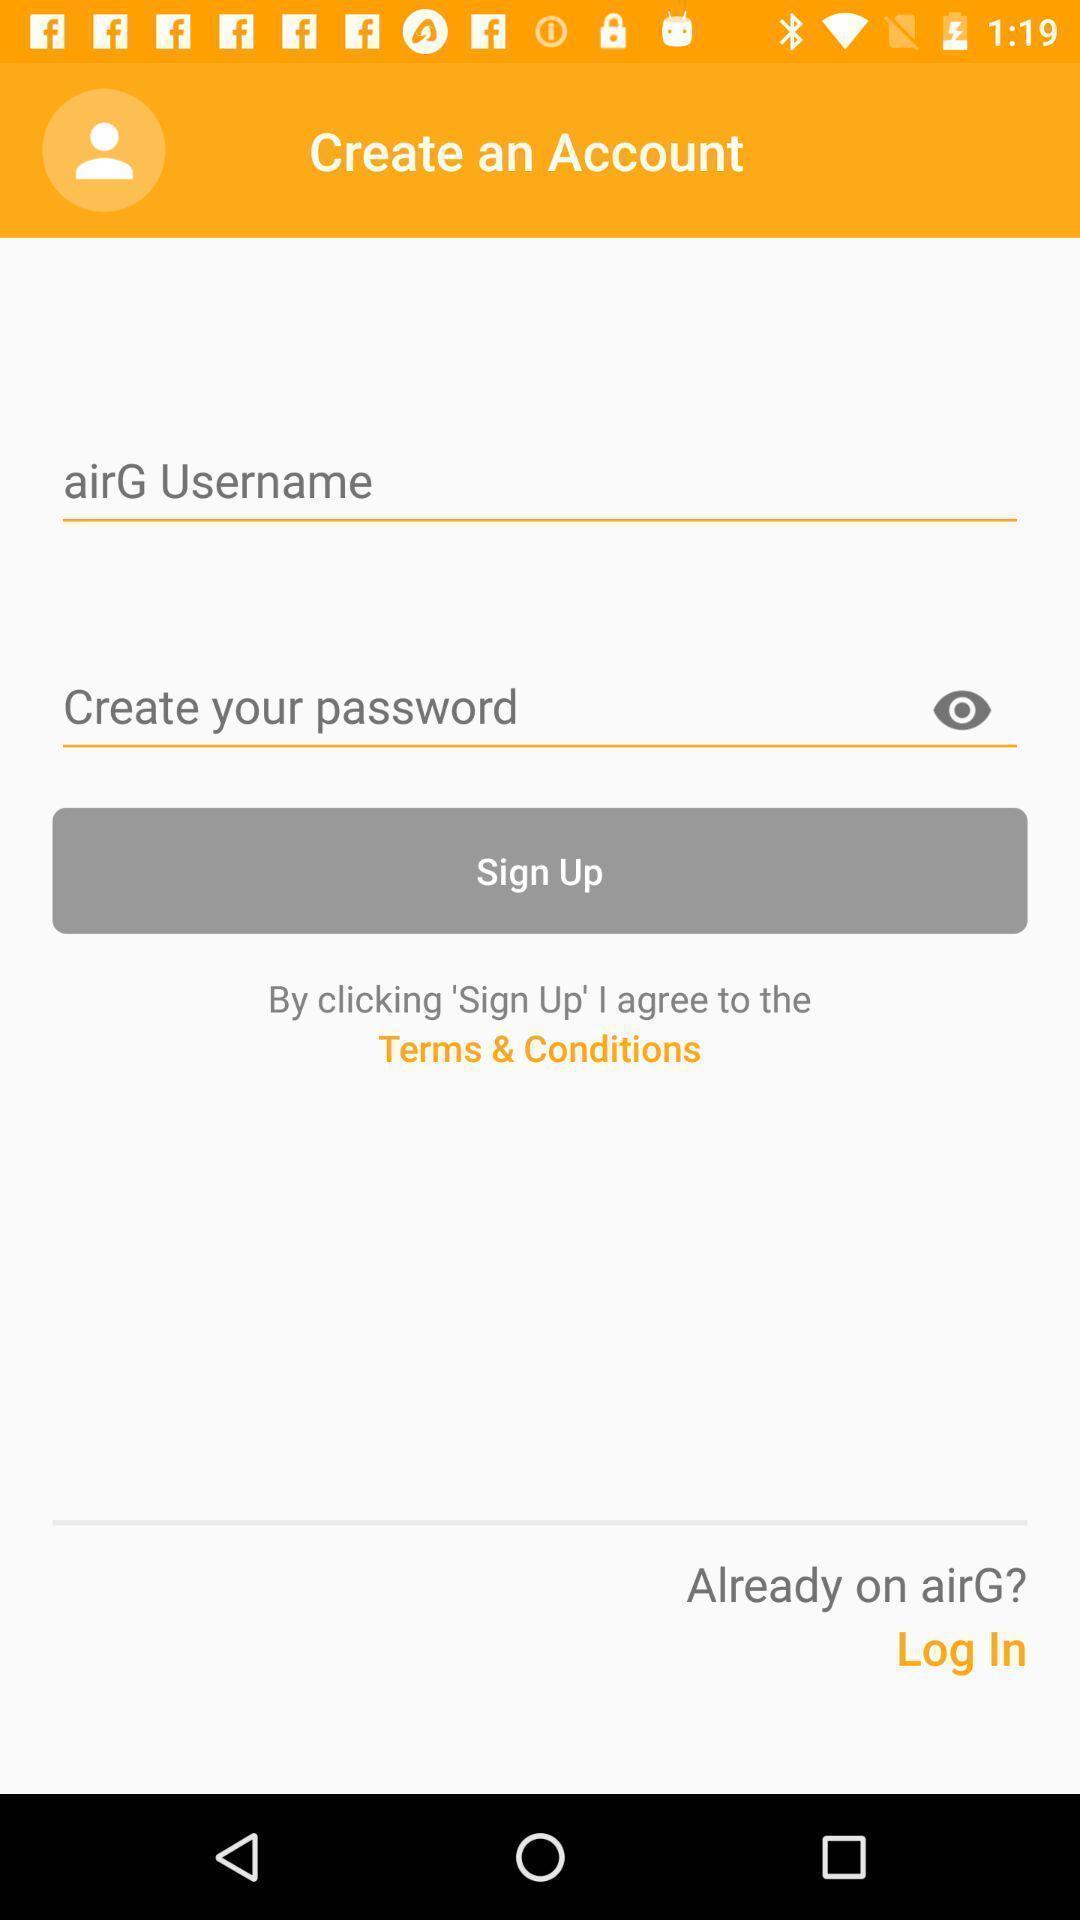Describe the content in this image. Sign up page to create an account. 